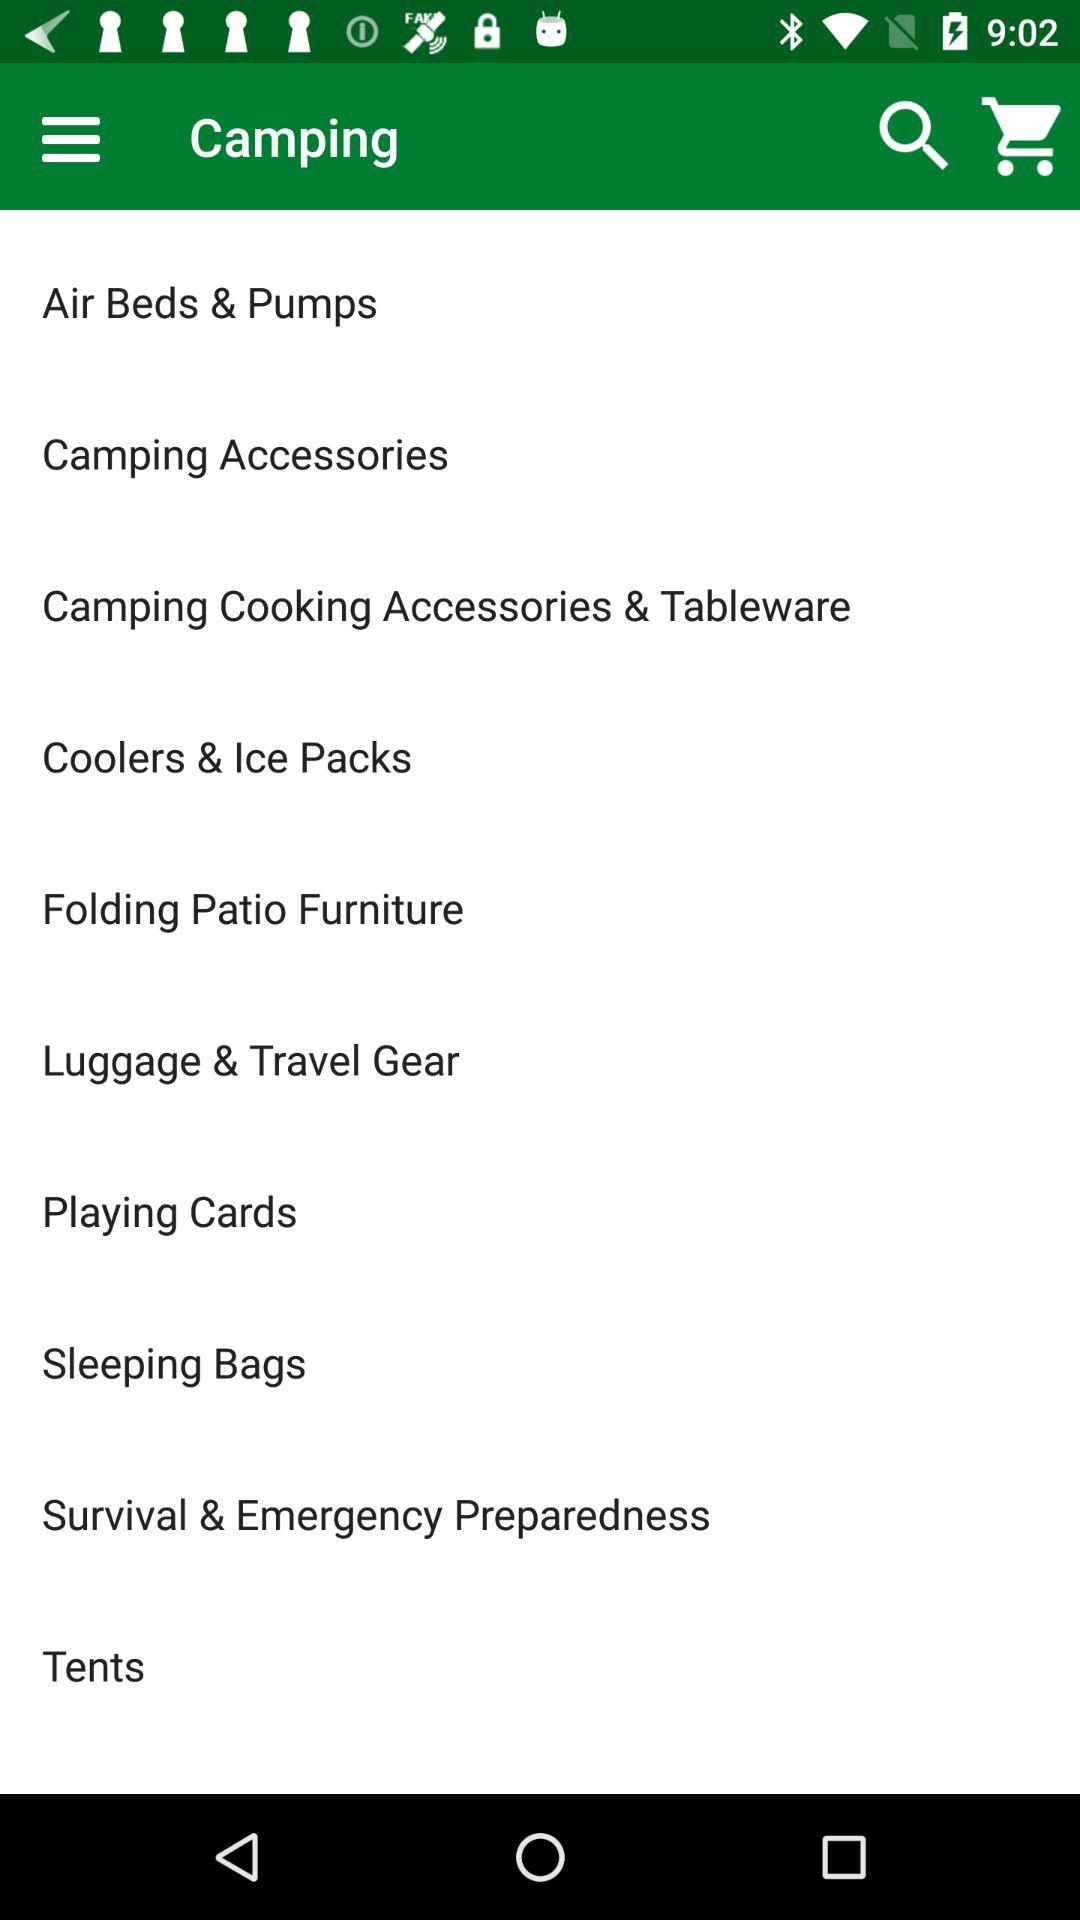What are the facilities we are getting in the camping? The facilities are "Air Beds & Pumps", "Camping Accessories", "Camping Cooking Accessories & Tableware", "Coolers & Ice Packs", "Folding Patio Furniture", "Luggage & Travel Gear", "Playing Cards", "Sleeping Bags", "Survival & Emergency Preparedness" and "Tents". 